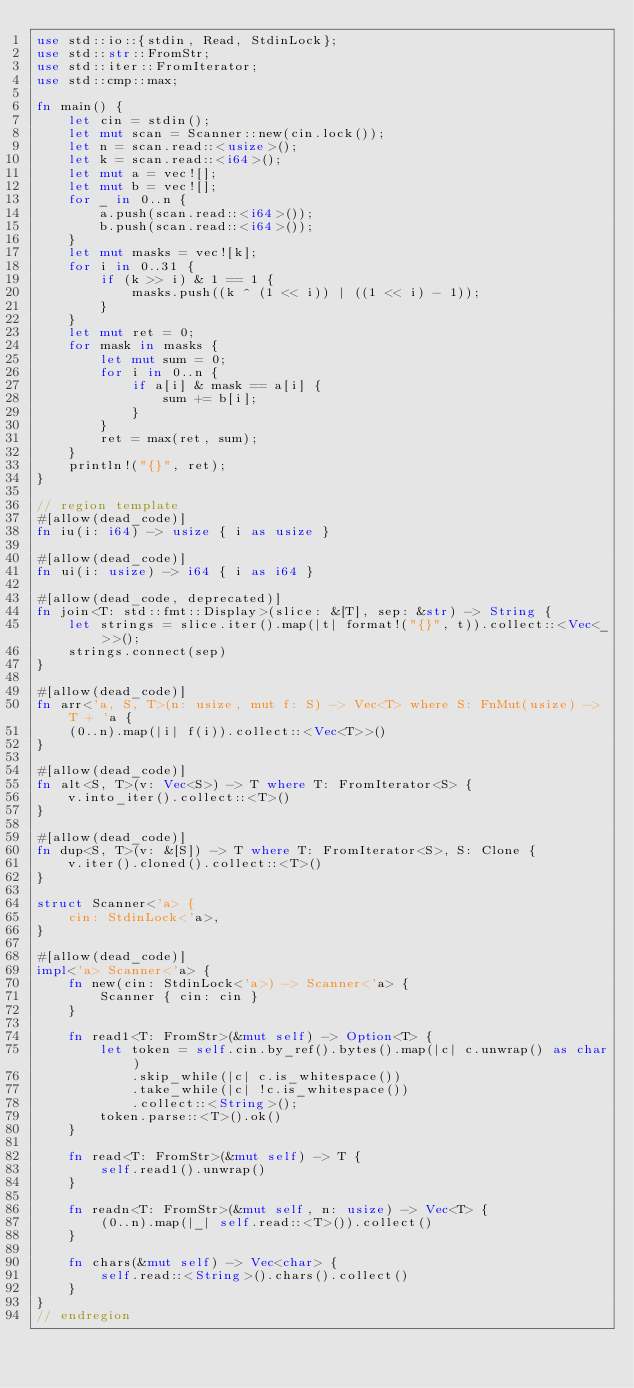<code> <loc_0><loc_0><loc_500><loc_500><_Rust_>use std::io::{stdin, Read, StdinLock};
use std::str::FromStr;
use std::iter::FromIterator;
use std::cmp::max;

fn main() {
    let cin = stdin();
    let mut scan = Scanner::new(cin.lock());
    let n = scan.read::<usize>();
    let k = scan.read::<i64>();
    let mut a = vec![];
    let mut b = vec![];
    for _ in 0..n {
        a.push(scan.read::<i64>());
        b.push(scan.read::<i64>());
    }
    let mut masks = vec![k];
    for i in 0..31 {
        if (k >> i) & 1 == 1 {
            masks.push((k ^ (1 << i)) | ((1 << i) - 1));
        }
    }
    let mut ret = 0;
    for mask in masks {
        let mut sum = 0;
        for i in 0..n {
            if a[i] & mask == a[i] {
                sum += b[i];
            }
        }
        ret = max(ret, sum);
    }
    println!("{}", ret);
}

// region template
#[allow(dead_code)]
fn iu(i: i64) -> usize { i as usize }

#[allow(dead_code)]
fn ui(i: usize) -> i64 { i as i64 }

#[allow(dead_code, deprecated)]
fn join<T: std::fmt::Display>(slice: &[T], sep: &str) -> String {
    let strings = slice.iter().map(|t| format!("{}", t)).collect::<Vec<_>>();
    strings.connect(sep)
}

#[allow(dead_code)]
fn arr<'a, S, T>(n: usize, mut f: S) -> Vec<T> where S: FnMut(usize) -> T + 'a {
    (0..n).map(|i| f(i)).collect::<Vec<T>>()
}

#[allow(dead_code)]
fn alt<S, T>(v: Vec<S>) -> T where T: FromIterator<S> {
    v.into_iter().collect::<T>()
}

#[allow(dead_code)]
fn dup<S, T>(v: &[S]) -> T where T: FromIterator<S>, S: Clone {
    v.iter().cloned().collect::<T>()
}

struct Scanner<'a> {
    cin: StdinLock<'a>,
}

#[allow(dead_code)]
impl<'a> Scanner<'a> {
    fn new(cin: StdinLock<'a>) -> Scanner<'a> {
        Scanner { cin: cin }
    }

    fn read1<T: FromStr>(&mut self) -> Option<T> {
        let token = self.cin.by_ref().bytes().map(|c| c.unwrap() as char)
            .skip_while(|c| c.is_whitespace())
            .take_while(|c| !c.is_whitespace())
            .collect::<String>();
        token.parse::<T>().ok()
    }

    fn read<T: FromStr>(&mut self) -> T {
        self.read1().unwrap()
    }

    fn readn<T: FromStr>(&mut self, n: usize) -> Vec<T> {
        (0..n).map(|_| self.read::<T>()).collect()
    }

    fn chars(&mut self) -> Vec<char> {
        self.read::<String>().chars().collect()
    }
}
// endregion</code> 